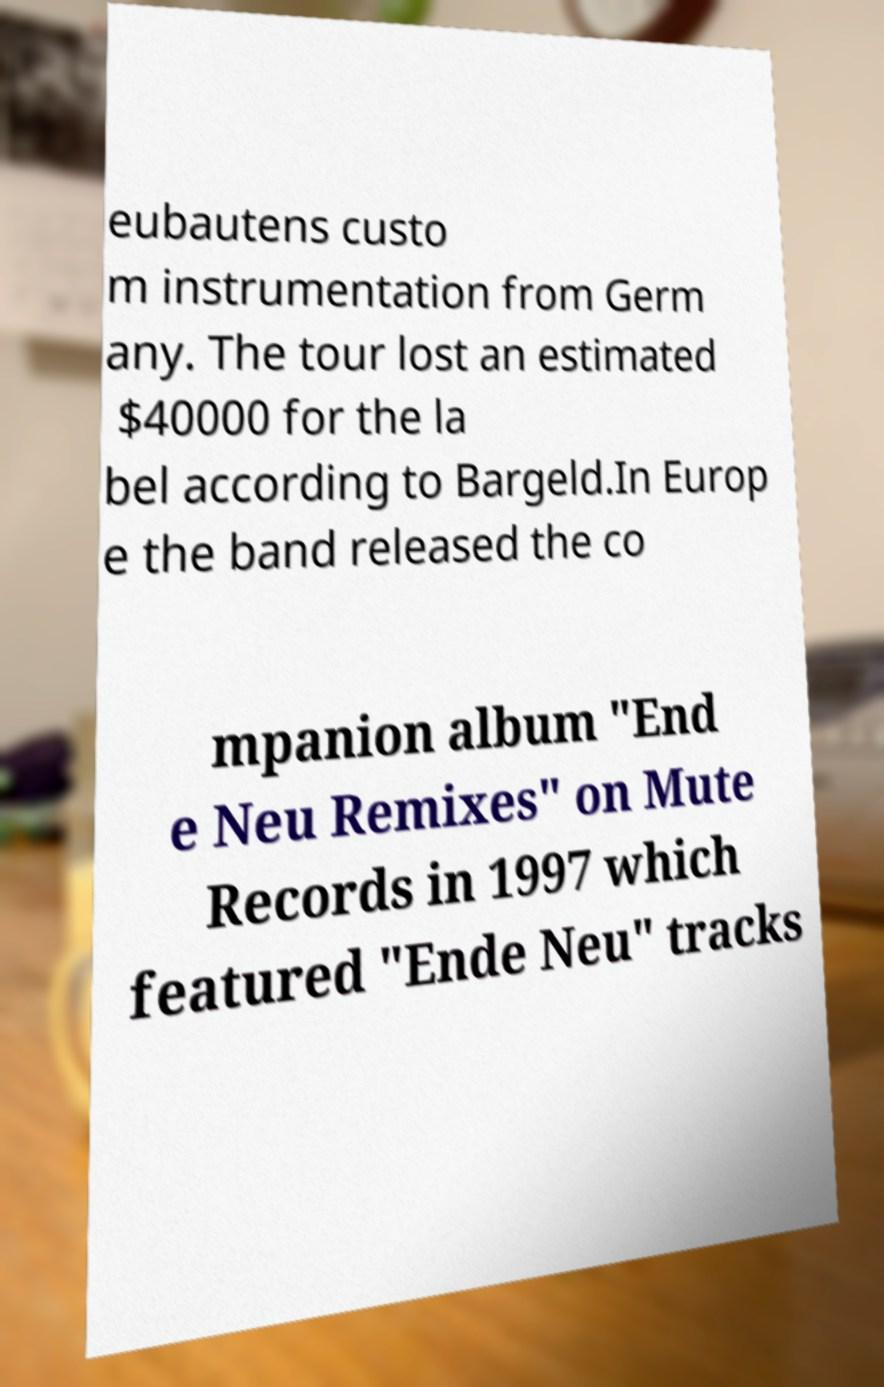Can you accurately transcribe the text from the provided image for me? eubautens custo m instrumentation from Germ any. The tour lost an estimated $40000 for the la bel according to Bargeld.In Europ e the band released the co mpanion album "End e Neu Remixes" on Mute Records in 1997 which featured "Ende Neu" tracks 